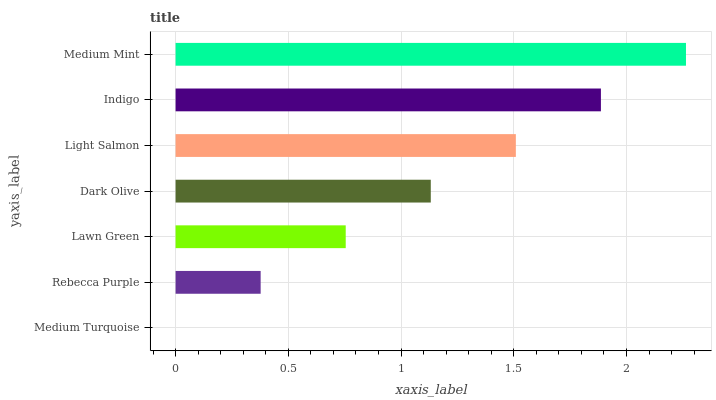Is Medium Turquoise the minimum?
Answer yes or no. Yes. Is Medium Mint the maximum?
Answer yes or no. Yes. Is Rebecca Purple the minimum?
Answer yes or no. No. Is Rebecca Purple the maximum?
Answer yes or no. No. Is Rebecca Purple greater than Medium Turquoise?
Answer yes or no. Yes. Is Medium Turquoise less than Rebecca Purple?
Answer yes or no. Yes. Is Medium Turquoise greater than Rebecca Purple?
Answer yes or no. No. Is Rebecca Purple less than Medium Turquoise?
Answer yes or no. No. Is Dark Olive the high median?
Answer yes or no. Yes. Is Dark Olive the low median?
Answer yes or no. Yes. Is Medium Turquoise the high median?
Answer yes or no. No. Is Light Salmon the low median?
Answer yes or no. No. 